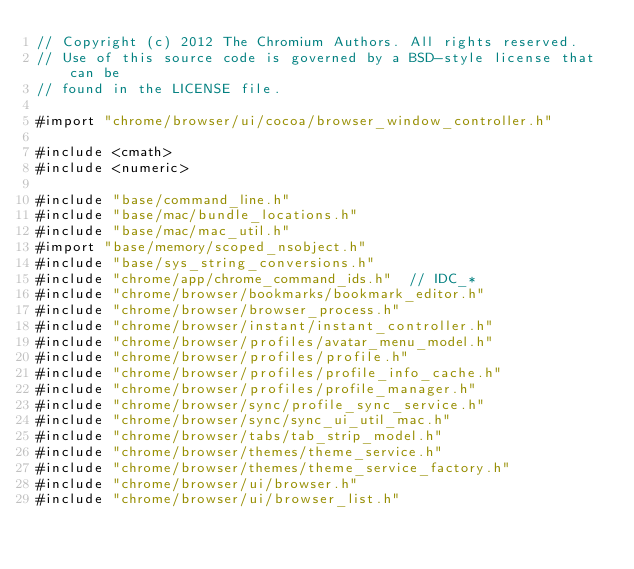<code> <loc_0><loc_0><loc_500><loc_500><_ObjectiveC_>// Copyright (c) 2012 The Chromium Authors. All rights reserved.
// Use of this source code is governed by a BSD-style license that can be
// found in the LICENSE file.

#import "chrome/browser/ui/cocoa/browser_window_controller.h"

#include <cmath>
#include <numeric>

#include "base/command_line.h"
#include "base/mac/bundle_locations.h"
#include "base/mac/mac_util.h"
#import "base/memory/scoped_nsobject.h"
#include "base/sys_string_conversions.h"
#include "chrome/app/chrome_command_ids.h"  // IDC_*
#include "chrome/browser/bookmarks/bookmark_editor.h"
#include "chrome/browser/browser_process.h"
#include "chrome/browser/instant/instant_controller.h"
#include "chrome/browser/profiles/avatar_menu_model.h"
#include "chrome/browser/profiles/profile.h"
#include "chrome/browser/profiles/profile_info_cache.h"
#include "chrome/browser/profiles/profile_manager.h"
#include "chrome/browser/sync/profile_sync_service.h"
#include "chrome/browser/sync/sync_ui_util_mac.h"
#include "chrome/browser/tabs/tab_strip_model.h"
#include "chrome/browser/themes/theme_service.h"
#include "chrome/browser/themes/theme_service_factory.h"
#include "chrome/browser/ui/browser.h"
#include "chrome/browser/ui/browser_list.h"</code> 